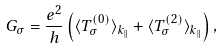Convert formula to latex. <formula><loc_0><loc_0><loc_500><loc_500>G _ { \sigma } = \frac { e ^ { 2 } } { h } \left ( \langle T _ { \sigma } ^ { ( 0 ) } \rangle _ { k _ { \| } } + \langle T _ { \sigma } ^ { ( 2 ) } \rangle _ { k _ { \| } } \right ) ,</formula> 